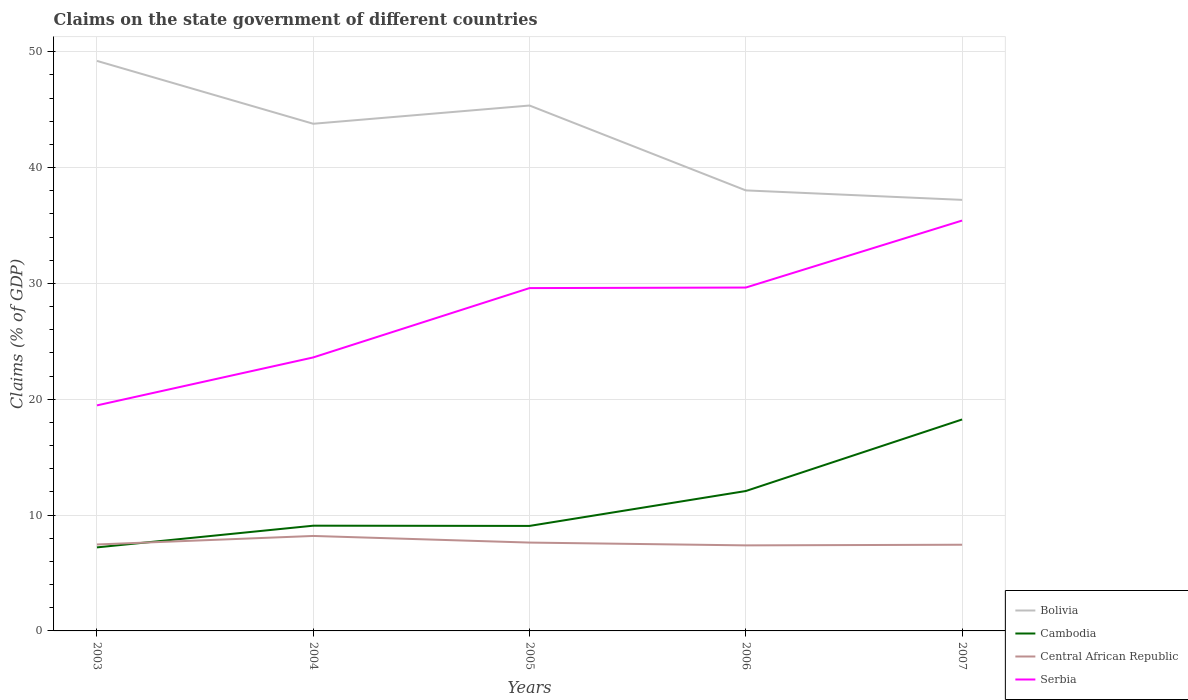Across all years, what is the maximum percentage of GDP claimed on the state government in Bolivia?
Your answer should be very brief. 37.21. What is the total percentage of GDP claimed on the state government in Serbia in the graph?
Provide a short and direct response. -10.13. What is the difference between the highest and the second highest percentage of GDP claimed on the state government in Central African Republic?
Provide a short and direct response. 0.81. How many lines are there?
Ensure brevity in your answer.  4. What is the difference between two consecutive major ticks on the Y-axis?
Make the answer very short. 10. Where does the legend appear in the graph?
Provide a succinct answer. Bottom right. How many legend labels are there?
Keep it short and to the point. 4. How are the legend labels stacked?
Keep it short and to the point. Vertical. What is the title of the graph?
Offer a terse response. Claims on the state government of different countries. Does "Netherlands" appear as one of the legend labels in the graph?
Ensure brevity in your answer.  No. What is the label or title of the Y-axis?
Ensure brevity in your answer.  Claims (% of GDP). What is the Claims (% of GDP) of Bolivia in 2003?
Ensure brevity in your answer.  49.2. What is the Claims (% of GDP) in Cambodia in 2003?
Provide a short and direct response. 7.21. What is the Claims (% of GDP) in Central African Republic in 2003?
Offer a very short reply. 7.46. What is the Claims (% of GDP) in Serbia in 2003?
Provide a short and direct response. 19.47. What is the Claims (% of GDP) in Bolivia in 2004?
Ensure brevity in your answer.  43.78. What is the Claims (% of GDP) of Cambodia in 2004?
Your response must be concise. 9.08. What is the Claims (% of GDP) of Central African Republic in 2004?
Your response must be concise. 8.2. What is the Claims (% of GDP) in Serbia in 2004?
Ensure brevity in your answer.  23.61. What is the Claims (% of GDP) in Bolivia in 2005?
Provide a short and direct response. 45.35. What is the Claims (% of GDP) in Cambodia in 2005?
Provide a short and direct response. 9.06. What is the Claims (% of GDP) in Central African Republic in 2005?
Your response must be concise. 7.63. What is the Claims (% of GDP) in Serbia in 2005?
Offer a terse response. 29.59. What is the Claims (% of GDP) in Bolivia in 2006?
Ensure brevity in your answer.  38.03. What is the Claims (% of GDP) in Cambodia in 2006?
Offer a very short reply. 12.08. What is the Claims (% of GDP) of Central African Republic in 2006?
Your response must be concise. 7.38. What is the Claims (% of GDP) in Serbia in 2006?
Your response must be concise. 29.64. What is the Claims (% of GDP) of Bolivia in 2007?
Provide a succinct answer. 37.21. What is the Claims (% of GDP) of Cambodia in 2007?
Make the answer very short. 18.25. What is the Claims (% of GDP) in Central African Republic in 2007?
Keep it short and to the point. 7.44. What is the Claims (% of GDP) of Serbia in 2007?
Provide a short and direct response. 35.42. Across all years, what is the maximum Claims (% of GDP) in Bolivia?
Provide a short and direct response. 49.2. Across all years, what is the maximum Claims (% of GDP) of Cambodia?
Ensure brevity in your answer.  18.25. Across all years, what is the maximum Claims (% of GDP) of Central African Republic?
Your response must be concise. 8.2. Across all years, what is the maximum Claims (% of GDP) of Serbia?
Your answer should be very brief. 35.42. Across all years, what is the minimum Claims (% of GDP) of Bolivia?
Your response must be concise. 37.21. Across all years, what is the minimum Claims (% of GDP) of Cambodia?
Your answer should be compact. 7.21. Across all years, what is the minimum Claims (% of GDP) of Central African Republic?
Your response must be concise. 7.38. Across all years, what is the minimum Claims (% of GDP) in Serbia?
Offer a terse response. 19.47. What is the total Claims (% of GDP) of Bolivia in the graph?
Your response must be concise. 213.57. What is the total Claims (% of GDP) in Cambodia in the graph?
Offer a terse response. 55.69. What is the total Claims (% of GDP) of Central African Republic in the graph?
Your answer should be compact. 38.11. What is the total Claims (% of GDP) in Serbia in the graph?
Offer a terse response. 137.73. What is the difference between the Claims (% of GDP) of Bolivia in 2003 and that in 2004?
Provide a short and direct response. 5.43. What is the difference between the Claims (% of GDP) in Cambodia in 2003 and that in 2004?
Your answer should be very brief. -1.87. What is the difference between the Claims (% of GDP) in Central African Republic in 2003 and that in 2004?
Your response must be concise. -0.73. What is the difference between the Claims (% of GDP) of Serbia in 2003 and that in 2004?
Your answer should be very brief. -4.14. What is the difference between the Claims (% of GDP) in Bolivia in 2003 and that in 2005?
Provide a short and direct response. 3.85. What is the difference between the Claims (% of GDP) in Cambodia in 2003 and that in 2005?
Make the answer very short. -1.85. What is the difference between the Claims (% of GDP) in Central African Republic in 2003 and that in 2005?
Your response must be concise. -0.16. What is the difference between the Claims (% of GDP) in Serbia in 2003 and that in 2005?
Provide a short and direct response. -10.13. What is the difference between the Claims (% of GDP) of Bolivia in 2003 and that in 2006?
Your answer should be very brief. 11.18. What is the difference between the Claims (% of GDP) in Cambodia in 2003 and that in 2006?
Provide a succinct answer. -4.86. What is the difference between the Claims (% of GDP) in Central African Republic in 2003 and that in 2006?
Your response must be concise. 0.08. What is the difference between the Claims (% of GDP) in Serbia in 2003 and that in 2006?
Offer a terse response. -10.17. What is the difference between the Claims (% of GDP) of Bolivia in 2003 and that in 2007?
Your answer should be compact. 12. What is the difference between the Claims (% of GDP) in Cambodia in 2003 and that in 2007?
Provide a short and direct response. -11.04. What is the difference between the Claims (% of GDP) in Central African Republic in 2003 and that in 2007?
Provide a succinct answer. 0.02. What is the difference between the Claims (% of GDP) in Serbia in 2003 and that in 2007?
Offer a very short reply. -15.96. What is the difference between the Claims (% of GDP) in Bolivia in 2004 and that in 2005?
Give a very brief answer. -1.57. What is the difference between the Claims (% of GDP) in Cambodia in 2004 and that in 2005?
Offer a very short reply. 0.02. What is the difference between the Claims (% of GDP) of Central African Republic in 2004 and that in 2005?
Offer a very short reply. 0.57. What is the difference between the Claims (% of GDP) of Serbia in 2004 and that in 2005?
Make the answer very short. -5.99. What is the difference between the Claims (% of GDP) of Bolivia in 2004 and that in 2006?
Your answer should be compact. 5.75. What is the difference between the Claims (% of GDP) of Cambodia in 2004 and that in 2006?
Ensure brevity in your answer.  -2.99. What is the difference between the Claims (% of GDP) in Central African Republic in 2004 and that in 2006?
Your answer should be very brief. 0.81. What is the difference between the Claims (% of GDP) in Serbia in 2004 and that in 2006?
Offer a terse response. -6.03. What is the difference between the Claims (% of GDP) in Bolivia in 2004 and that in 2007?
Your answer should be compact. 6.57. What is the difference between the Claims (% of GDP) of Cambodia in 2004 and that in 2007?
Make the answer very short. -9.17. What is the difference between the Claims (% of GDP) in Central African Republic in 2004 and that in 2007?
Ensure brevity in your answer.  0.76. What is the difference between the Claims (% of GDP) of Serbia in 2004 and that in 2007?
Your response must be concise. -11.82. What is the difference between the Claims (% of GDP) of Bolivia in 2005 and that in 2006?
Make the answer very short. 7.33. What is the difference between the Claims (% of GDP) of Cambodia in 2005 and that in 2006?
Give a very brief answer. -3.01. What is the difference between the Claims (% of GDP) of Central African Republic in 2005 and that in 2006?
Offer a very short reply. 0.24. What is the difference between the Claims (% of GDP) of Serbia in 2005 and that in 2006?
Provide a succinct answer. -0.05. What is the difference between the Claims (% of GDP) of Bolivia in 2005 and that in 2007?
Keep it short and to the point. 8.14. What is the difference between the Claims (% of GDP) in Cambodia in 2005 and that in 2007?
Offer a very short reply. -9.19. What is the difference between the Claims (% of GDP) of Central African Republic in 2005 and that in 2007?
Make the answer very short. 0.19. What is the difference between the Claims (% of GDP) of Serbia in 2005 and that in 2007?
Provide a succinct answer. -5.83. What is the difference between the Claims (% of GDP) in Bolivia in 2006 and that in 2007?
Give a very brief answer. 0.82. What is the difference between the Claims (% of GDP) in Cambodia in 2006 and that in 2007?
Make the answer very short. -6.18. What is the difference between the Claims (% of GDP) of Central African Republic in 2006 and that in 2007?
Offer a terse response. -0.06. What is the difference between the Claims (% of GDP) of Serbia in 2006 and that in 2007?
Your answer should be compact. -5.78. What is the difference between the Claims (% of GDP) of Bolivia in 2003 and the Claims (% of GDP) of Cambodia in 2004?
Your answer should be compact. 40.12. What is the difference between the Claims (% of GDP) of Bolivia in 2003 and the Claims (% of GDP) of Central African Republic in 2004?
Keep it short and to the point. 41.01. What is the difference between the Claims (% of GDP) in Bolivia in 2003 and the Claims (% of GDP) in Serbia in 2004?
Your response must be concise. 25.6. What is the difference between the Claims (% of GDP) of Cambodia in 2003 and the Claims (% of GDP) of Central African Republic in 2004?
Ensure brevity in your answer.  -0.99. What is the difference between the Claims (% of GDP) in Cambodia in 2003 and the Claims (% of GDP) in Serbia in 2004?
Ensure brevity in your answer.  -16.4. What is the difference between the Claims (% of GDP) in Central African Republic in 2003 and the Claims (% of GDP) in Serbia in 2004?
Offer a terse response. -16.15. What is the difference between the Claims (% of GDP) of Bolivia in 2003 and the Claims (% of GDP) of Cambodia in 2005?
Make the answer very short. 40.14. What is the difference between the Claims (% of GDP) of Bolivia in 2003 and the Claims (% of GDP) of Central African Republic in 2005?
Your answer should be very brief. 41.58. What is the difference between the Claims (% of GDP) of Bolivia in 2003 and the Claims (% of GDP) of Serbia in 2005?
Keep it short and to the point. 19.61. What is the difference between the Claims (% of GDP) in Cambodia in 2003 and the Claims (% of GDP) in Central African Republic in 2005?
Ensure brevity in your answer.  -0.41. What is the difference between the Claims (% of GDP) in Cambodia in 2003 and the Claims (% of GDP) in Serbia in 2005?
Offer a very short reply. -22.38. What is the difference between the Claims (% of GDP) in Central African Republic in 2003 and the Claims (% of GDP) in Serbia in 2005?
Your answer should be very brief. -22.13. What is the difference between the Claims (% of GDP) in Bolivia in 2003 and the Claims (% of GDP) in Cambodia in 2006?
Provide a succinct answer. 37.13. What is the difference between the Claims (% of GDP) in Bolivia in 2003 and the Claims (% of GDP) in Central African Republic in 2006?
Your answer should be compact. 41.82. What is the difference between the Claims (% of GDP) of Bolivia in 2003 and the Claims (% of GDP) of Serbia in 2006?
Give a very brief answer. 19.56. What is the difference between the Claims (% of GDP) of Cambodia in 2003 and the Claims (% of GDP) of Central African Republic in 2006?
Keep it short and to the point. -0.17. What is the difference between the Claims (% of GDP) of Cambodia in 2003 and the Claims (% of GDP) of Serbia in 2006?
Offer a terse response. -22.43. What is the difference between the Claims (% of GDP) in Central African Republic in 2003 and the Claims (% of GDP) in Serbia in 2006?
Offer a terse response. -22.18. What is the difference between the Claims (% of GDP) in Bolivia in 2003 and the Claims (% of GDP) in Cambodia in 2007?
Provide a short and direct response. 30.95. What is the difference between the Claims (% of GDP) of Bolivia in 2003 and the Claims (% of GDP) of Central African Republic in 2007?
Your response must be concise. 41.77. What is the difference between the Claims (% of GDP) in Bolivia in 2003 and the Claims (% of GDP) in Serbia in 2007?
Give a very brief answer. 13.78. What is the difference between the Claims (% of GDP) of Cambodia in 2003 and the Claims (% of GDP) of Central African Republic in 2007?
Give a very brief answer. -0.23. What is the difference between the Claims (% of GDP) in Cambodia in 2003 and the Claims (% of GDP) in Serbia in 2007?
Give a very brief answer. -28.21. What is the difference between the Claims (% of GDP) of Central African Republic in 2003 and the Claims (% of GDP) of Serbia in 2007?
Your answer should be very brief. -27.96. What is the difference between the Claims (% of GDP) of Bolivia in 2004 and the Claims (% of GDP) of Cambodia in 2005?
Keep it short and to the point. 34.71. What is the difference between the Claims (% of GDP) in Bolivia in 2004 and the Claims (% of GDP) in Central African Republic in 2005?
Ensure brevity in your answer.  36.15. What is the difference between the Claims (% of GDP) of Bolivia in 2004 and the Claims (% of GDP) of Serbia in 2005?
Give a very brief answer. 14.18. What is the difference between the Claims (% of GDP) in Cambodia in 2004 and the Claims (% of GDP) in Central African Republic in 2005?
Make the answer very short. 1.46. What is the difference between the Claims (% of GDP) of Cambodia in 2004 and the Claims (% of GDP) of Serbia in 2005?
Give a very brief answer. -20.51. What is the difference between the Claims (% of GDP) in Central African Republic in 2004 and the Claims (% of GDP) in Serbia in 2005?
Offer a very short reply. -21.4. What is the difference between the Claims (% of GDP) of Bolivia in 2004 and the Claims (% of GDP) of Cambodia in 2006?
Offer a terse response. 31.7. What is the difference between the Claims (% of GDP) of Bolivia in 2004 and the Claims (% of GDP) of Central African Republic in 2006?
Give a very brief answer. 36.39. What is the difference between the Claims (% of GDP) of Bolivia in 2004 and the Claims (% of GDP) of Serbia in 2006?
Ensure brevity in your answer.  14.14. What is the difference between the Claims (% of GDP) of Cambodia in 2004 and the Claims (% of GDP) of Central African Republic in 2006?
Provide a short and direct response. 1.7. What is the difference between the Claims (% of GDP) of Cambodia in 2004 and the Claims (% of GDP) of Serbia in 2006?
Offer a terse response. -20.56. What is the difference between the Claims (% of GDP) in Central African Republic in 2004 and the Claims (% of GDP) in Serbia in 2006?
Keep it short and to the point. -21.44. What is the difference between the Claims (% of GDP) in Bolivia in 2004 and the Claims (% of GDP) in Cambodia in 2007?
Ensure brevity in your answer.  25.53. What is the difference between the Claims (% of GDP) of Bolivia in 2004 and the Claims (% of GDP) of Central African Republic in 2007?
Offer a terse response. 36.34. What is the difference between the Claims (% of GDP) in Bolivia in 2004 and the Claims (% of GDP) in Serbia in 2007?
Your answer should be compact. 8.36. What is the difference between the Claims (% of GDP) of Cambodia in 2004 and the Claims (% of GDP) of Central African Republic in 2007?
Ensure brevity in your answer.  1.64. What is the difference between the Claims (% of GDP) in Cambodia in 2004 and the Claims (% of GDP) in Serbia in 2007?
Your answer should be compact. -26.34. What is the difference between the Claims (% of GDP) of Central African Republic in 2004 and the Claims (% of GDP) of Serbia in 2007?
Give a very brief answer. -27.23. What is the difference between the Claims (% of GDP) in Bolivia in 2005 and the Claims (% of GDP) in Cambodia in 2006?
Offer a very short reply. 33.28. What is the difference between the Claims (% of GDP) of Bolivia in 2005 and the Claims (% of GDP) of Central African Republic in 2006?
Keep it short and to the point. 37.97. What is the difference between the Claims (% of GDP) of Bolivia in 2005 and the Claims (% of GDP) of Serbia in 2006?
Provide a short and direct response. 15.71. What is the difference between the Claims (% of GDP) of Cambodia in 2005 and the Claims (% of GDP) of Central African Republic in 2006?
Ensure brevity in your answer.  1.68. What is the difference between the Claims (% of GDP) of Cambodia in 2005 and the Claims (% of GDP) of Serbia in 2006?
Give a very brief answer. -20.58. What is the difference between the Claims (% of GDP) of Central African Republic in 2005 and the Claims (% of GDP) of Serbia in 2006?
Ensure brevity in your answer.  -22.01. What is the difference between the Claims (% of GDP) of Bolivia in 2005 and the Claims (% of GDP) of Cambodia in 2007?
Provide a short and direct response. 27.1. What is the difference between the Claims (% of GDP) of Bolivia in 2005 and the Claims (% of GDP) of Central African Republic in 2007?
Ensure brevity in your answer.  37.91. What is the difference between the Claims (% of GDP) of Bolivia in 2005 and the Claims (% of GDP) of Serbia in 2007?
Provide a succinct answer. 9.93. What is the difference between the Claims (% of GDP) in Cambodia in 2005 and the Claims (% of GDP) in Central African Republic in 2007?
Give a very brief answer. 1.62. What is the difference between the Claims (% of GDP) of Cambodia in 2005 and the Claims (% of GDP) of Serbia in 2007?
Offer a terse response. -26.36. What is the difference between the Claims (% of GDP) in Central African Republic in 2005 and the Claims (% of GDP) in Serbia in 2007?
Your answer should be compact. -27.8. What is the difference between the Claims (% of GDP) of Bolivia in 2006 and the Claims (% of GDP) of Cambodia in 2007?
Your response must be concise. 19.77. What is the difference between the Claims (% of GDP) of Bolivia in 2006 and the Claims (% of GDP) of Central African Republic in 2007?
Make the answer very short. 30.59. What is the difference between the Claims (% of GDP) in Bolivia in 2006 and the Claims (% of GDP) in Serbia in 2007?
Your response must be concise. 2.6. What is the difference between the Claims (% of GDP) in Cambodia in 2006 and the Claims (% of GDP) in Central African Republic in 2007?
Offer a very short reply. 4.64. What is the difference between the Claims (% of GDP) in Cambodia in 2006 and the Claims (% of GDP) in Serbia in 2007?
Offer a terse response. -23.35. What is the difference between the Claims (% of GDP) in Central African Republic in 2006 and the Claims (% of GDP) in Serbia in 2007?
Your response must be concise. -28.04. What is the average Claims (% of GDP) in Bolivia per year?
Provide a succinct answer. 42.71. What is the average Claims (% of GDP) of Cambodia per year?
Offer a very short reply. 11.14. What is the average Claims (% of GDP) of Central African Republic per year?
Your answer should be compact. 7.62. What is the average Claims (% of GDP) in Serbia per year?
Your answer should be very brief. 27.55. In the year 2003, what is the difference between the Claims (% of GDP) of Bolivia and Claims (% of GDP) of Cambodia?
Your response must be concise. 41.99. In the year 2003, what is the difference between the Claims (% of GDP) in Bolivia and Claims (% of GDP) in Central African Republic?
Ensure brevity in your answer.  41.74. In the year 2003, what is the difference between the Claims (% of GDP) of Bolivia and Claims (% of GDP) of Serbia?
Offer a very short reply. 29.74. In the year 2003, what is the difference between the Claims (% of GDP) in Cambodia and Claims (% of GDP) in Central African Republic?
Make the answer very short. -0.25. In the year 2003, what is the difference between the Claims (% of GDP) in Cambodia and Claims (% of GDP) in Serbia?
Ensure brevity in your answer.  -12.26. In the year 2003, what is the difference between the Claims (% of GDP) of Central African Republic and Claims (% of GDP) of Serbia?
Make the answer very short. -12.01. In the year 2004, what is the difference between the Claims (% of GDP) of Bolivia and Claims (% of GDP) of Cambodia?
Provide a short and direct response. 34.7. In the year 2004, what is the difference between the Claims (% of GDP) in Bolivia and Claims (% of GDP) in Central African Republic?
Give a very brief answer. 35.58. In the year 2004, what is the difference between the Claims (% of GDP) in Bolivia and Claims (% of GDP) in Serbia?
Make the answer very short. 20.17. In the year 2004, what is the difference between the Claims (% of GDP) in Cambodia and Claims (% of GDP) in Central African Republic?
Ensure brevity in your answer.  0.89. In the year 2004, what is the difference between the Claims (% of GDP) in Cambodia and Claims (% of GDP) in Serbia?
Offer a terse response. -14.53. In the year 2004, what is the difference between the Claims (% of GDP) of Central African Republic and Claims (% of GDP) of Serbia?
Keep it short and to the point. -15.41. In the year 2005, what is the difference between the Claims (% of GDP) of Bolivia and Claims (% of GDP) of Cambodia?
Provide a succinct answer. 36.29. In the year 2005, what is the difference between the Claims (% of GDP) in Bolivia and Claims (% of GDP) in Central African Republic?
Ensure brevity in your answer.  37.73. In the year 2005, what is the difference between the Claims (% of GDP) in Bolivia and Claims (% of GDP) in Serbia?
Give a very brief answer. 15.76. In the year 2005, what is the difference between the Claims (% of GDP) in Cambodia and Claims (% of GDP) in Central African Republic?
Make the answer very short. 1.44. In the year 2005, what is the difference between the Claims (% of GDP) of Cambodia and Claims (% of GDP) of Serbia?
Ensure brevity in your answer.  -20.53. In the year 2005, what is the difference between the Claims (% of GDP) in Central African Republic and Claims (% of GDP) in Serbia?
Give a very brief answer. -21.97. In the year 2006, what is the difference between the Claims (% of GDP) in Bolivia and Claims (% of GDP) in Cambodia?
Your answer should be compact. 25.95. In the year 2006, what is the difference between the Claims (% of GDP) in Bolivia and Claims (% of GDP) in Central African Republic?
Ensure brevity in your answer.  30.64. In the year 2006, what is the difference between the Claims (% of GDP) in Bolivia and Claims (% of GDP) in Serbia?
Your answer should be compact. 8.39. In the year 2006, what is the difference between the Claims (% of GDP) in Cambodia and Claims (% of GDP) in Central African Republic?
Make the answer very short. 4.69. In the year 2006, what is the difference between the Claims (% of GDP) of Cambodia and Claims (% of GDP) of Serbia?
Make the answer very short. -17.56. In the year 2006, what is the difference between the Claims (% of GDP) of Central African Republic and Claims (% of GDP) of Serbia?
Offer a very short reply. -22.26. In the year 2007, what is the difference between the Claims (% of GDP) of Bolivia and Claims (% of GDP) of Cambodia?
Your answer should be very brief. 18.96. In the year 2007, what is the difference between the Claims (% of GDP) of Bolivia and Claims (% of GDP) of Central African Republic?
Your response must be concise. 29.77. In the year 2007, what is the difference between the Claims (% of GDP) of Bolivia and Claims (% of GDP) of Serbia?
Your response must be concise. 1.79. In the year 2007, what is the difference between the Claims (% of GDP) in Cambodia and Claims (% of GDP) in Central African Republic?
Your answer should be very brief. 10.81. In the year 2007, what is the difference between the Claims (% of GDP) of Cambodia and Claims (% of GDP) of Serbia?
Offer a very short reply. -17.17. In the year 2007, what is the difference between the Claims (% of GDP) in Central African Republic and Claims (% of GDP) in Serbia?
Your response must be concise. -27.98. What is the ratio of the Claims (% of GDP) of Bolivia in 2003 to that in 2004?
Make the answer very short. 1.12. What is the ratio of the Claims (% of GDP) in Cambodia in 2003 to that in 2004?
Provide a succinct answer. 0.79. What is the ratio of the Claims (% of GDP) in Central African Republic in 2003 to that in 2004?
Give a very brief answer. 0.91. What is the ratio of the Claims (% of GDP) of Serbia in 2003 to that in 2004?
Your response must be concise. 0.82. What is the ratio of the Claims (% of GDP) of Bolivia in 2003 to that in 2005?
Offer a terse response. 1.08. What is the ratio of the Claims (% of GDP) of Cambodia in 2003 to that in 2005?
Make the answer very short. 0.8. What is the ratio of the Claims (% of GDP) in Central African Republic in 2003 to that in 2005?
Give a very brief answer. 0.98. What is the ratio of the Claims (% of GDP) of Serbia in 2003 to that in 2005?
Your answer should be compact. 0.66. What is the ratio of the Claims (% of GDP) of Bolivia in 2003 to that in 2006?
Offer a very short reply. 1.29. What is the ratio of the Claims (% of GDP) in Cambodia in 2003 to that in 2006?
Offer a very short reply. 0.6. What is the ratio of the Claims (% of GDP) in Central African Republic in 2003 to that in 2006?
Your answer should be very brief. 1.01. What is the ratio of the Claims (% of GDP) in Serbia in 2003 to that in 2006?
Provide a short and direct response. 0.66. What is the ratio of the Claims (% of GDP) in Bolivia in 2003 to that in 2007?
Your answer should be very brief. 1.32. What is the ratio of the Claims (% of GDP) of Cambodia in 2003 to that in 2007?
Your answer should be compact. 0.4. What is the ratio of the Claims (% of GDP) of Serbia in 2003 to that in 2007?
Your response must be concise. 0.55. What is the ratio of the Claims (% of GDP) in Bolivia in 2004 to that in 2005?
Provide a short and direct response. 0.97. What is the ratio of the Claims (% of GDP) in Central African Republic in 2004 to that in 2005?
Offer a very short reply. 1.08. What is the ratio of the Claims (% of GDP) in Serbia in 2004 to that in 2005?
Keep it short and to the point. 0.8. What is the ratio of the Claims (% of GDP) of Bolivia in 2004 to that in 2006?
Offer a very short reply. 1.15. What is the ratio of the Claims (% of GDP) in Cambodia in 2004 to that in 2006?
Provide a short and direct response. 0.75. What is the ratio of the Claims (% of GDP) of Central African Republic in 2004 to that in 2006?
Make the answer very short. 1.11. What is the ratio of the Claims (% of GDP) of Serbia in 2004 to that in 2006?
Provide a short and direct response. 0.8. What is the ratio of the Claims (% of GDP) of Bolivia in 2004 to that in 2007?
Give a very brief answer. 1.18. What is the ratio of the Claims (% of GDP) in Cambodia in 2004 to that in 2007?
Offer a very short reply. 0.5. What is the ratio of the Claims (% of GDP) in Central African Republic in 2004 to that in 2007?
Offer a terse response. 1.1. What is the ratio of the Claims (% of GDP) in Serbia in 2004 to that in 2007?
Provide a succinct answer. 0.67. What is the ratio of the Claims (% of GDP) in Bolivia in 2005 to that in 2006?
Your response must be concise. 1.19. What is the ratio of the Claims (% of GDP) in Cambodia in 2005 to that in 2006?
Your response must be concise. 0.75. What is the ratio of the Claims (% of GDP) in Central African Republic in 2005 to that in 2006?
Offer a very short reply. 1.03. What is the ratio of the Claims (% of GDP) of Bolivia in 2005 to that in 2007?
Give a very brief answer. 1.22. What is the ratio of the Claims (% of GDP) in Cambodia in 2005 to that in 2007?
Offer a terse response. 0.5. What is the ratio of the Claims (% of GDP) of Central African Republic in 2005 to that in 2007?
Make the answer very short. 1.02. What is the ratio of the Claims (% of GDP) of Serbia in 2005 to that in 2007?
Provide a short and direct response. 0.84. What is the ratio of the Claims (% of GDP) of Cambodia in 2006 to that in 2007?
Provide a succinct answer. 0.66. What is the ratio of the Claims (% of GDP) in Central African Republic in 2006 to that in 2007?
Offer a very short reply. 0.99. What is the ratio of the Claims (% of GDP) in Serbia in 2006 to that in 2007?
Make the answer very short. 0.84. What is the difference between the highest and the second highest Claims (% of GDP) in Bolivia?
Ensure brevity in your answer.  3.85. What is the difference between the highest and the second highest Claims (% of GDP) of Cambodia?
Ensure brevity in your answer.  6.18. What is the difference between the highest and the second highest Claims (% of GDP) in Central African Republic?
Ensure brevity in your answer.  0.57. What is the difference between the highest and the second highest Claims (% of GDP) in Serbia?
Offer a terse response. 5.78. What is the difference between the highest and the lowest Claims (% of GDP) of Bolivia?
Make the answer very short. 12. What is the difference between the highest and the lowest Claims (% of GDP) in Cambodia?
Provide a short and direct response. 11.04. What is the difference between the highest and the lowest Claims (% of GDP) in Central African Republic?
Provide a succinct answer. 0.81. What is the difference between the highest and the lowest Claims (% of GDP) in Serbia?
Make the answer very short. 15.96. 